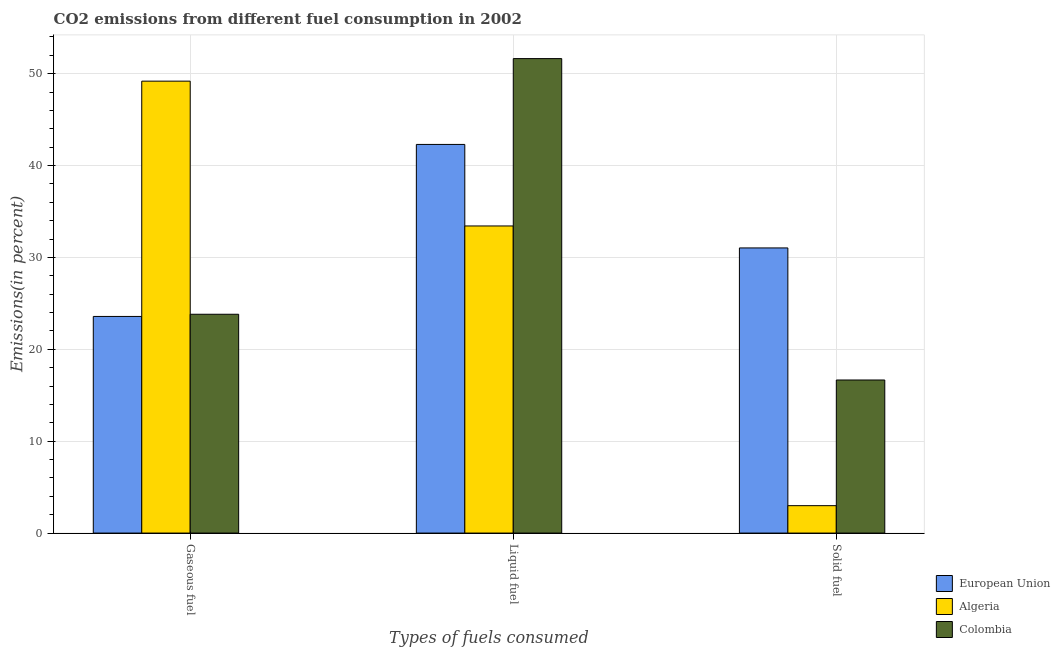Are the number of bars per tick equal to the number of legend labels?
Your response must be concise. Yes. How many bars are there on the 2nd tick from the right?
Give a very brief answer. 3. What is the label of the 3rd group of bars from the left?
Your response must be concise. Solid fuel. What is the percentage of solid fuel emission in European Union?
Ensure brevity in your answer.  31.04. Across all countries, what is the maximum percentage of solid fuel emission?
Provide a succinct answer. 31.04. Across all countries, what is the minimum percentage of solid fuel emission?
Offer a terse response. 2.98. In which country was the percentage of gaseous fuel emission maximum?
Make the answer very short. Algeria. In which country was the percentage of liquid fuel emission minimum?
Your response must be concise. Algeria. What is the total percentage of gaseous fuel emission in the graph?
Provide a short and direct response. 96.58. What is the difference between the percentage of liquid fuel emission in Algeria and that in European Union?
Ensure brevity in your answer.  -8.87. What is the difference between the percentage of solid fuel emission in European Union and the percentage of gaseous fuel emission in Colombia?
Offer a very short reply. 7.22. What is the average percentage of liquid fuel emission per country?
Offer a terse response. 42.46. What is the difference between the percentage of solid fuel emission and percentage of gaseous fuel emission in Colombia?
Give a very brief answer. -7.15. In how many countries, is the percentage of liquid fuel emission greater than 20 %?
Give a very brief answer. 3. What is the ratio of the percentage of gaseous fuel emission in Algeria to that in Colombia?
Offer a terse response. 2.07. Is the difference between the percentage of liquid fuel emission in Algeria and Colombia greater than the difference between the percentage of gaseous fuel emission in Algeria and Colombia?
Offer a terse response. No. What is the difference between the highest and the second highest percentage of solid fuel emission?
Ensure brevity in your answer.  14.37. What is the difference between the highest and the lowest percentage of liquid fuel emission?
Keep it short and to the point. 18.22. In how many countries, is the percentage of liquid fuel emission greater than the average percentage of liquid fuel emission taken over all countries?
Provide a short and direct response. 1. Is the sum of the percentage of liquid fuel emission in European Union and Colombia greater than the maximum percentage of solid fuel emission across all countries?
Keep it short and to the point. Yes. Is it the case that in every country, the sum of the percentage of gaseous fuel emission and percentage of liquid fuel emission is greater than the percentage of solid fuel emission?
Provide a succinct answer. Yes. How many bars are there?
Your response must be concise. 9. Are all the bars in the graph horizontal?
Provide a succinct answer. No. How many countries are there in the graph?
Give a very brief answer. 3. What is the difference between two consecutive major ticks on the Y-axis?
Offer a very short reply. 10. How many legend labels are there?
Ensure brevity in your answer.  3. What is the title of the graph?
Give a very brief answer. CO2 emissions from different fuel consumption in 2002. Does "Russian Federation" appear as one of the legend labels in the graph?
Provide a succinct answer. No. What is the label or title of the X-axis?
Offer a terse response. Types of fuels consumed. What is the label or title of the Y-axis?
Your answer should be compact. Emissions(in percent). What is the Emissions(in percent) of European Union in Gaseous fuel?
Offer a very short reply. 23.58. What is the Emissions(in percent) in Algeria in Gaseous fuel?
Your answer should be compact. 49.19. What is the Emissions(in percent) in Colombia in Gaseous fuel?
Give a very brief answer. 23.82. What is the Emissions(in percent) of European Union in Liquid fuel?
Offer a terse response. 42.3. What is the Emissions(in percent) in Algeria in Liquid fuel?
Your answer should be compact. 33.43. What is the Emissions(in percent) in Colombia in Liquid fuel?
Provide a short and direct response. 51.64. What is the Emissions(in percent) in European Union in Solid fuel?
Give a very brief answer. 31.04. What is the Emissions(in percent) in Algeria in Solid fuel?
Keep it short and to the point. 2.98. What is the Emissions(in percent) of Colombia in Solid fuel?
Provide a short and direct response. 16.66. Across all Types of fuels consumed, what is the maximum Emissions(in percent) in European Union?
Provide a succinct answer. 42.3. Across all Types of fuels consumed, what is the maximum Emissions(in percent) in Algeria?
Make the answer very short. 49.19. Across all Types of fuels consumed, what is the maximum Emissions(in percent) of Colombia?
Give a very brief answer. 51.64. Across all Types of fuels consumed, what is the minimum Emissions(in percent) in European Union?
Offer a very short reply. 23.58. Across all Types of fuels consumed, what is the minimum Emissions(in percent) in Algeria?
Keep it short and to the point. 2.98. Across all Types of fuels consumed, what is the minimum Emissions(in percent) of Colombia?
Provide a short and direct response. 16.66. What is the total Emissions(in percent) of European Union in the graph?
Give a very brief answer. 96.92. What is the total Emissions(in percent) of Algeria in the graph?
Ensure brevity in your answer.  85.6. What is the total Emissions(in percent) in Colombia in the graph?
Your answer should be very brief. 92.12. What is the difference between the Emissions(in percent) in European Union in Gaseous fuel and that in Liquid fuel?
Your answer should be very brief. -18.72. What is the difference between the Emissions(in percent) in Algeria in Gaseous fuel and that in Liquid fuel?
Provide a succinct answer. 15.76. What is the difference between the Emissions(in percent) in Colombia in Gaseous fuel and that in Liquid fuel?
Keep it short and to the point. -27.83. What is the difference between the Emissions(in percent) in European Union in Gaseous fuel and that in Solid fuel?
Offer a terse response. -7.46. What is the difference between the Emissions(in percent) in Algeria in Gaseous fuel and that in Solid fuel?
Ensure brevity in your answer.  46.21. What is the difference between the Emissions(in percent) in Colombia in Gaseous fuel and that in Solid fuel?
Keep it short and to the point. 7.15. What is the difference between the Emissions(in percent) in European Union in Liquid fuel and that in Solid fuel?
Give a very brief answer. 11.27. What is the difference between the Emissions(in percent) in Algeria in Liquid fuel and that in Solid fuel?
Provide a short and direct response. 30.44. What is the difference between the Emissions(in percent) in Colombia in Liquid fuel and that in Solid fuel?
Your answer should be very brief. 34.98. What is the difference between the Emissions(in percent) of European Union in Gaseous fuel and the Emissions(in percent) of Algeria in Liquid fuel?
Provide a short and direct response. -9.85. What is the difference between the Emissions(in percent) of European Union in Gaseous fuel and the Emissions(in percent) of Colombia in Liquid fuel?
Offer a terse response. -28.06. What is the difference between the Emissions(in percent) in Algeria in Gaseous fuel and the Emissions(in percent) in Colombia in Liquid fuel?
Offer a very short reply. -2.46. What is the difference between the Emissions(in percent) of European Union in Gaseous fuel and the Emissions(in percent) of Algeria in Solid fuel?
Keep it short and to the point. 20.6. What is the difference between the Emissions(in percent) in European Union in Gaseous fuel and the Emissions(in percent) in Colombia in Solid fuel?
Your answer should be very brief. 6.92. What is the difference between the Emissions(in percent) in Algeria in Gaseous fuel and the Emissions(in percent) in Colombia in Solid fuel?
Your answer should be compact. 32.53. What is the difference between the Emissions(in percent) in European Union in Liquid fuel and the Emissions(in percent) in Algeria in Solid fuel?
Provide a short and direct response. 39.32. What is the difference between the Emissions(in percent) of European Union in Liquid fuel and the Emissions(in percent) of Colombia in Solid fuel?
Offer a terse response. 25.64. What is the difference between the Emissions(in percent) of Algeria in Liquid fuel and the Emissions(in percent) of Colombia in Solid fuel?
Your answer should be very brief. 16.77. What is the average Emissions(in percent) of European Union per Types of fuels consumed?
Provide a succinct answer. 32.31. What is the average Emissions(in percent) in Algeria per Types of fuels consumed?
Provide a short and direct response. 28.53. What is the average Emissions(in percent) of Colombia per Types of fuels consumed?
Keep it short and to the point. 30.71. What is the difference between the Emissions(in percent) in European Union and Emissions(in percent) in Algeria in Gaseous fuel?
Keep it short and to the point. -25.61. What is the difference between the Emissions(in percent) of European Union and Emissions(in percent) of Colombia in Gaseous fuel?
Give a very brief answer. -0.24. What is the difference between the Emissions(in percent) in Algeria and Emissions(in percent) in Colombia in Gaseous fuel?
Provide a short and direct response. 25.37. What is the difference between the Emissions(in percent) of European Union and Emissions(in percent) of Algeria in Liquid fuel?
Offer a very short reply. 8.87. What is the difference between the Emissions(in percent) in European Union and Emissions(in percent) in Colombia in Liquid fuel?
Make the answer very short. -9.34. What is the difference between the Emissions(in percent) in Algeria and Emissions(in percent) in Colombia in Liquid fuel?
Your answer should be compact. -18.22. What is the difference between the Emissions(in percent) of European Union and Emissions(in percent) of Algeria in Solid fuel?
Provide a succinct answer. 28.05. What is the difference between the Emissions(in percent) of European Union and Emissions(in percent) of Colombia in Solid fuel?
Your answer should be compact. 14.37. What is the difference between the Emissions(in percent) in Algeria and Emissions(in percent) in Colombia in Solid fuel?
Give a very brief answer. -13.68. What is the ratio of the Emissions(in percent) of European Union in Gaseous fuel to that in Liquid fuel?
Your answer should be very brief. 0.56. What is the ratio of the Emissions(in percent) of Algeria in Gaseous fuel to that in Liquid fuel?
Your answer should be compact. 1.47. What is the ratio of the Emissions(in percent) of Colombia in Gaseous fuel to that in Liquid fuel?
Offer a very short reply. 0.46. What is the ratio of the Emissions(in percent) of European Union in Gaseous fuel to that in Solid fuel?
Provide a succinct answer. 0.76. What is the ratio of the Emissions(in percent) of Algeria in Gaseous fuel to that in Solid fuel?
Ensure brevity in your answer.  16.49. What is the ratio of the Emissions(in percent) of Colombia in Gaseous fuel to that in Solid fuel?
Keep it short and to the point. 1.43. What is the ratio of the Emissions(in percent) of European Union in Liquid fuel to that in Solid fuel?
Your response must be concise. 1.36. What is the ratio of the Emissions(in percent) of Algeria in Liquid fuel to that in Solid fuel?
Make the answer very short. 11.21. What is the ratio of the Emissions(in percent) in Colombia in Liquid fuel to that in Solid fuel?
Provide a succinct answer. 3.1. What is the difference between the highest and the second highest Emissions(in percent) in European Union?
Provide a succinct answer. 11.27. What is the difference between the highest and the second highest Emissions(in percent) of Algeria?
Offer a very short reply. 15.76. What is the difference between the highest and the second highest Emissions(in percent) in Colombia?
Give a very brief answer. 27.83. What is the difference between the highest and the lowest Emissions(in percent) of European Union?
Give a very brief answer. 18.72. What is the difference between the highest and the lowest Emissions(in percent) in Algeria?
Your answer should be compact. 46.21. What is the difference between the highest and the lowest Emissions(in percent) of Colombia?
Make the answer very short. 34.98. 